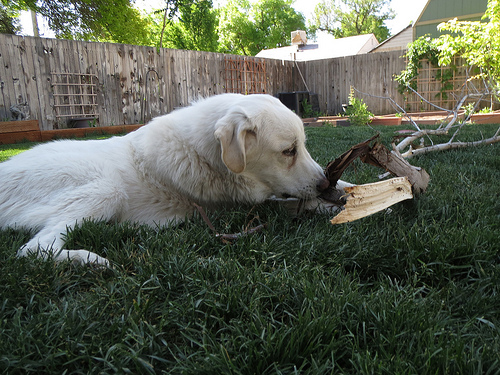<image>
Is the dog in the grass? No. The dog is not contained within the grass. These objects have a different spatial relationship. 